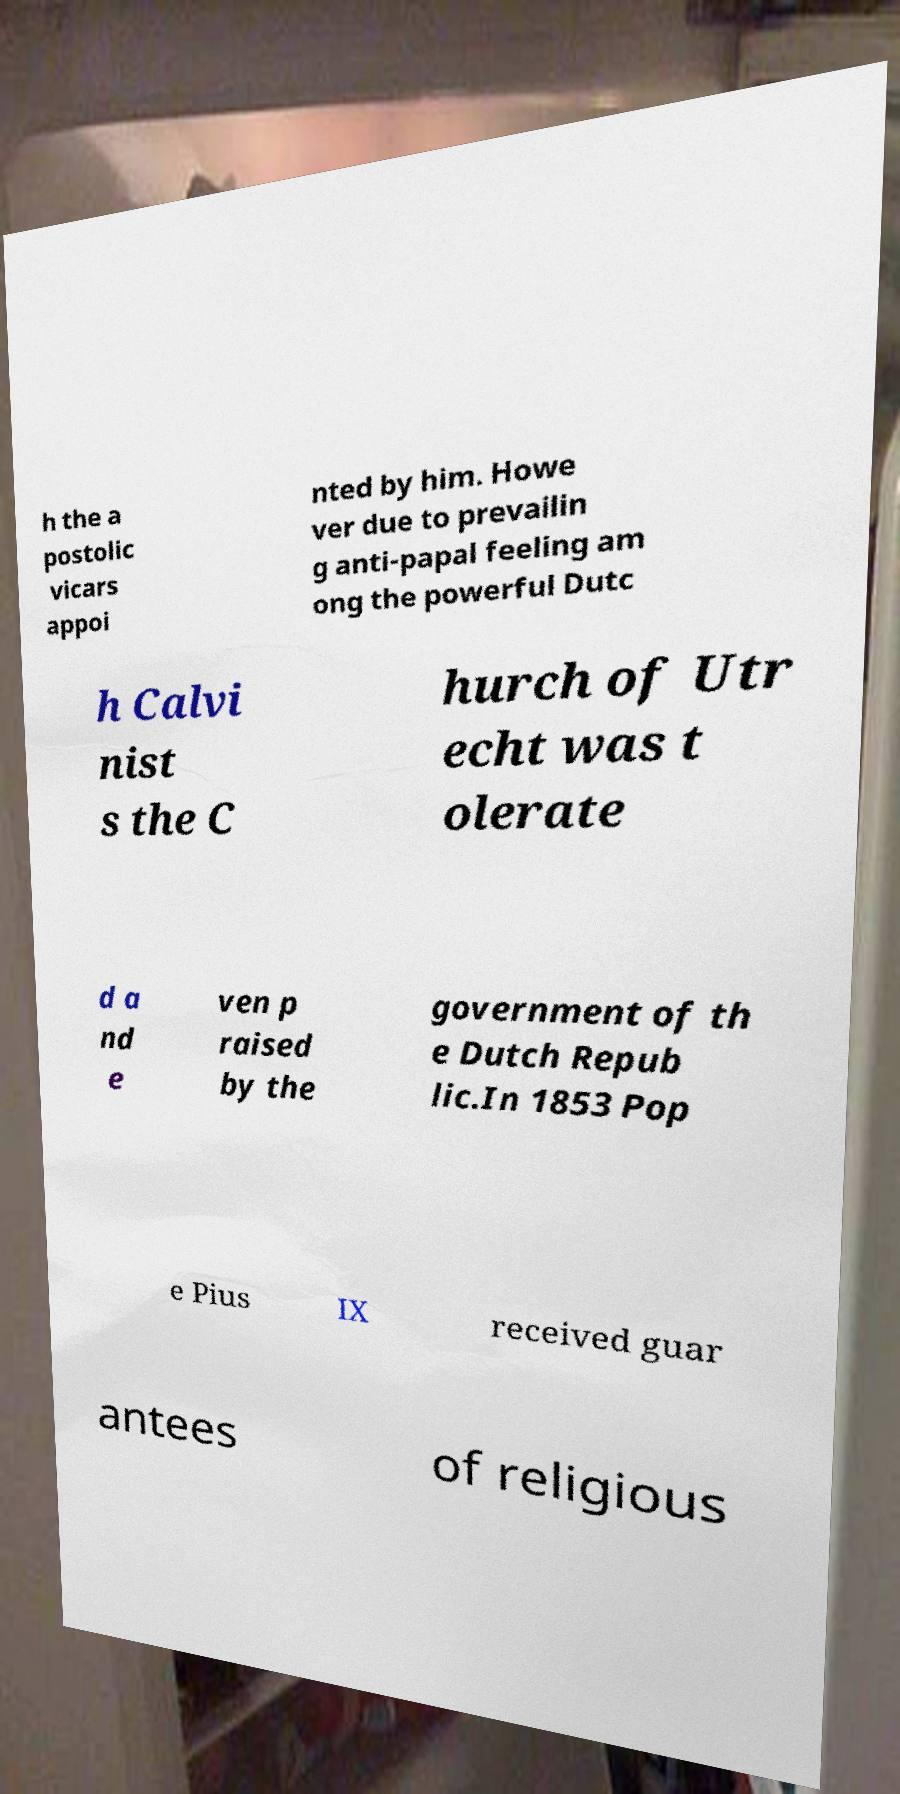For documentation purposes, I need the text within this image transcribed. Could you provide that? h the a postolic vicars appoi nted by him. Howe ver due to prevailin g anti-papal feeling am ong the powerful Dutc h Calvi nist s the C hurch of Utr echt was t olerate d a nd e ven p raised by the government of th e Dutch Repub lic.In 1853 Pop e Pius IX received guar antees of religious 